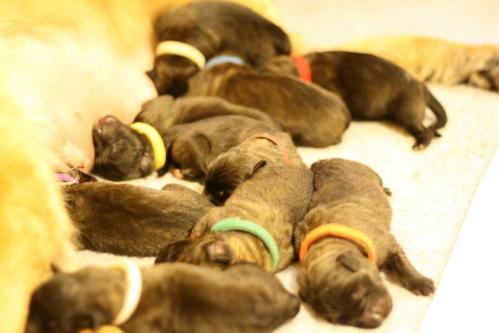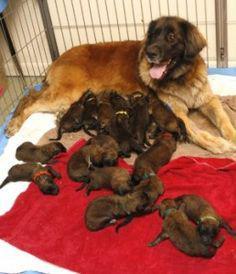The first image is the image on the left, the second image is the image on the right. Evaluate the accuracy of this statement regarding the images: "Right image shows a mother dog with raised head and her pups, surrounded by a natural wood border.". Is it true? Answer yes or no. No. The first image is the image on the left, the second image is the image on the right. Considering the images on both sides, is "The dog in the image on the right is nursing in an area surrounded by wooden planks." valid? Answer yes or no. No. 